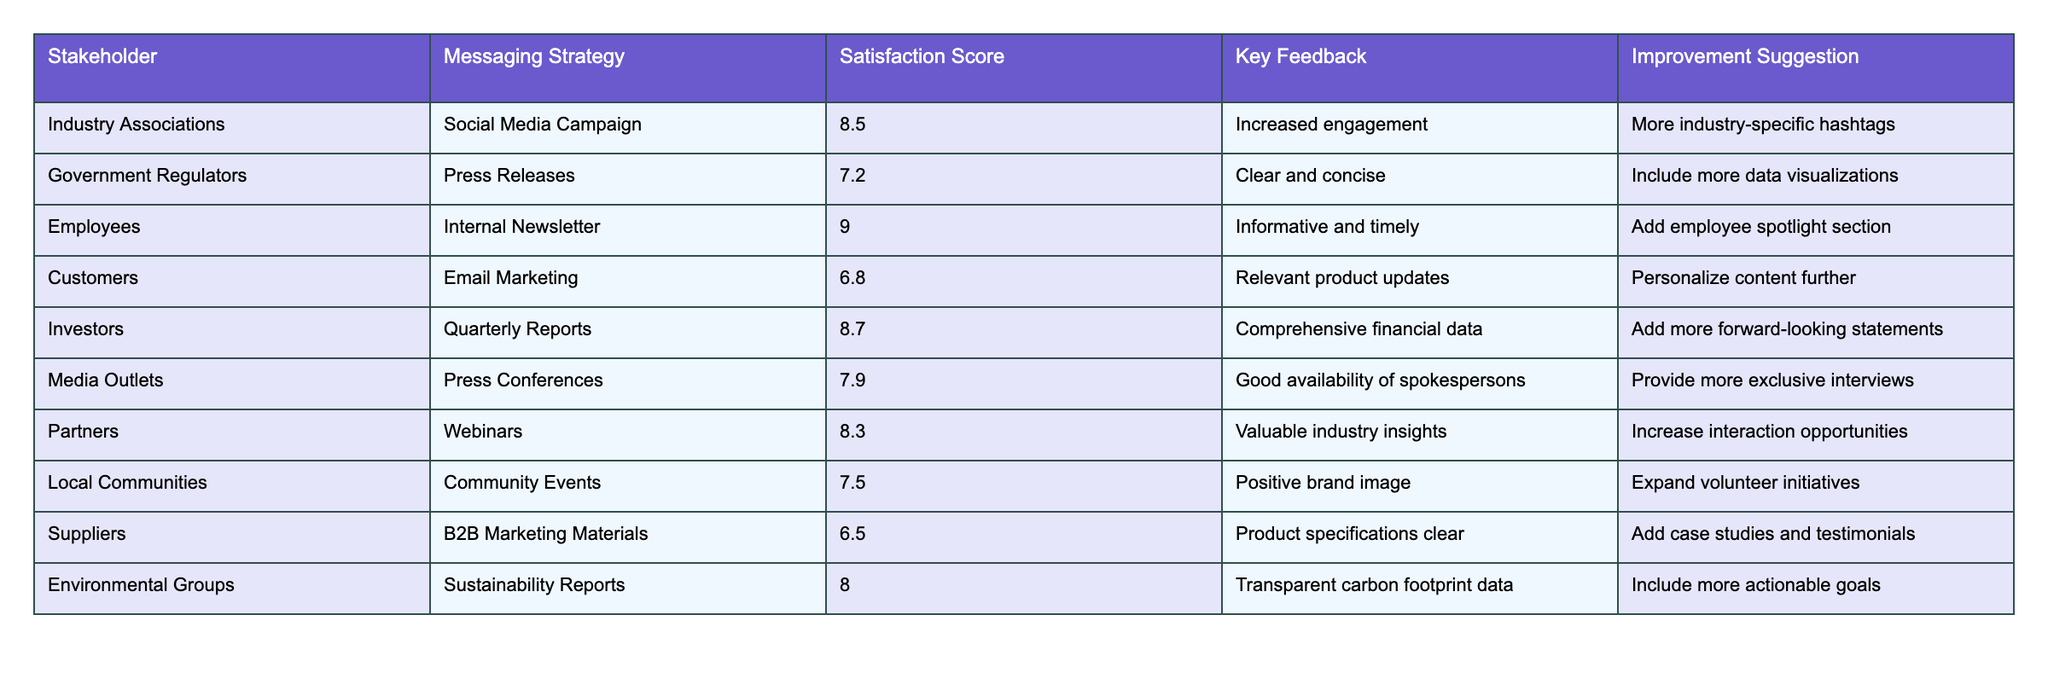What is the satisfaction score for Employees regarding the Internal Newsletter? The table indicates that the satisfaction score for Employees is specifically listed under that row, which shows a score of 9.0.
Answer: 9.0 Who provided the lowest satisfaction score, and what was it? The lowest satisfaction score is 6.5, which is given by Suppliers for B2B Marketing Materials, as indicated in the table.
Answer: Suppliers, 6.5 True or false: Environmental Groups gave a satisfaction score higher than 8.0. The table shows that Environmental Groups gave a satisfaction score of 8.0, which is not higher than 8.0; therefore, the statement is false.
Answer: False What is the average satisfaction score from the Industry Associations, Government Regulators, and Media Outlets? Summing the scores for these groups: 8.5 (Industry Associations) + 7.2 (Government Regulators) + 7.9 (Media Outlets) = 23.6. There are three scores, so the average is 23.6 / 3 = 7.87.
Answer: 7.87 How many stakeholders gave a satisfaction score of 8.0 or higher? By examining the table, we can count the rows with a satisfaction score of 8.0 or higher: Employees (9.0), Investors (8.7), Industry Associations (8.5), Partners (8.3), Environmental Groups (8.0) — totaling five stakeholders.
Answer: 5 Which messaging strategy received the highest satisfaction score, and who provided it? Looking at the scores, the Internal Newsletter associated with Employees has the highest score of 9.0, as shown in the table.
Answer: Internal Newsletter, Employees What improvement suggestion was made by Customers, and what was their satisfaction score? According to the table, Customers suggested "Personalize content further," and their corresponding satisfaction score is 6.8. Both pieces of information can be directly fetched from the row related to Customers.
Answer: Personalize content further, 6.8 What is the difference between the highest and lowest satisfaction scores? The highest score is 9.0 (Employees) and the lowest is 6.5 (Suppliers). The difference is calculated as 9.0 - 6.5 = 2.5.
Answer: 2.5 Which stakeholders requested more engagement opportunities or personalized content? By examining the improvement suggestions, Customers requested to "Personalize content further," and Partners suggested to "Increase interaction opportunities," showing both stakeholders sought greater engagement.
Answer: Customers, Partners 